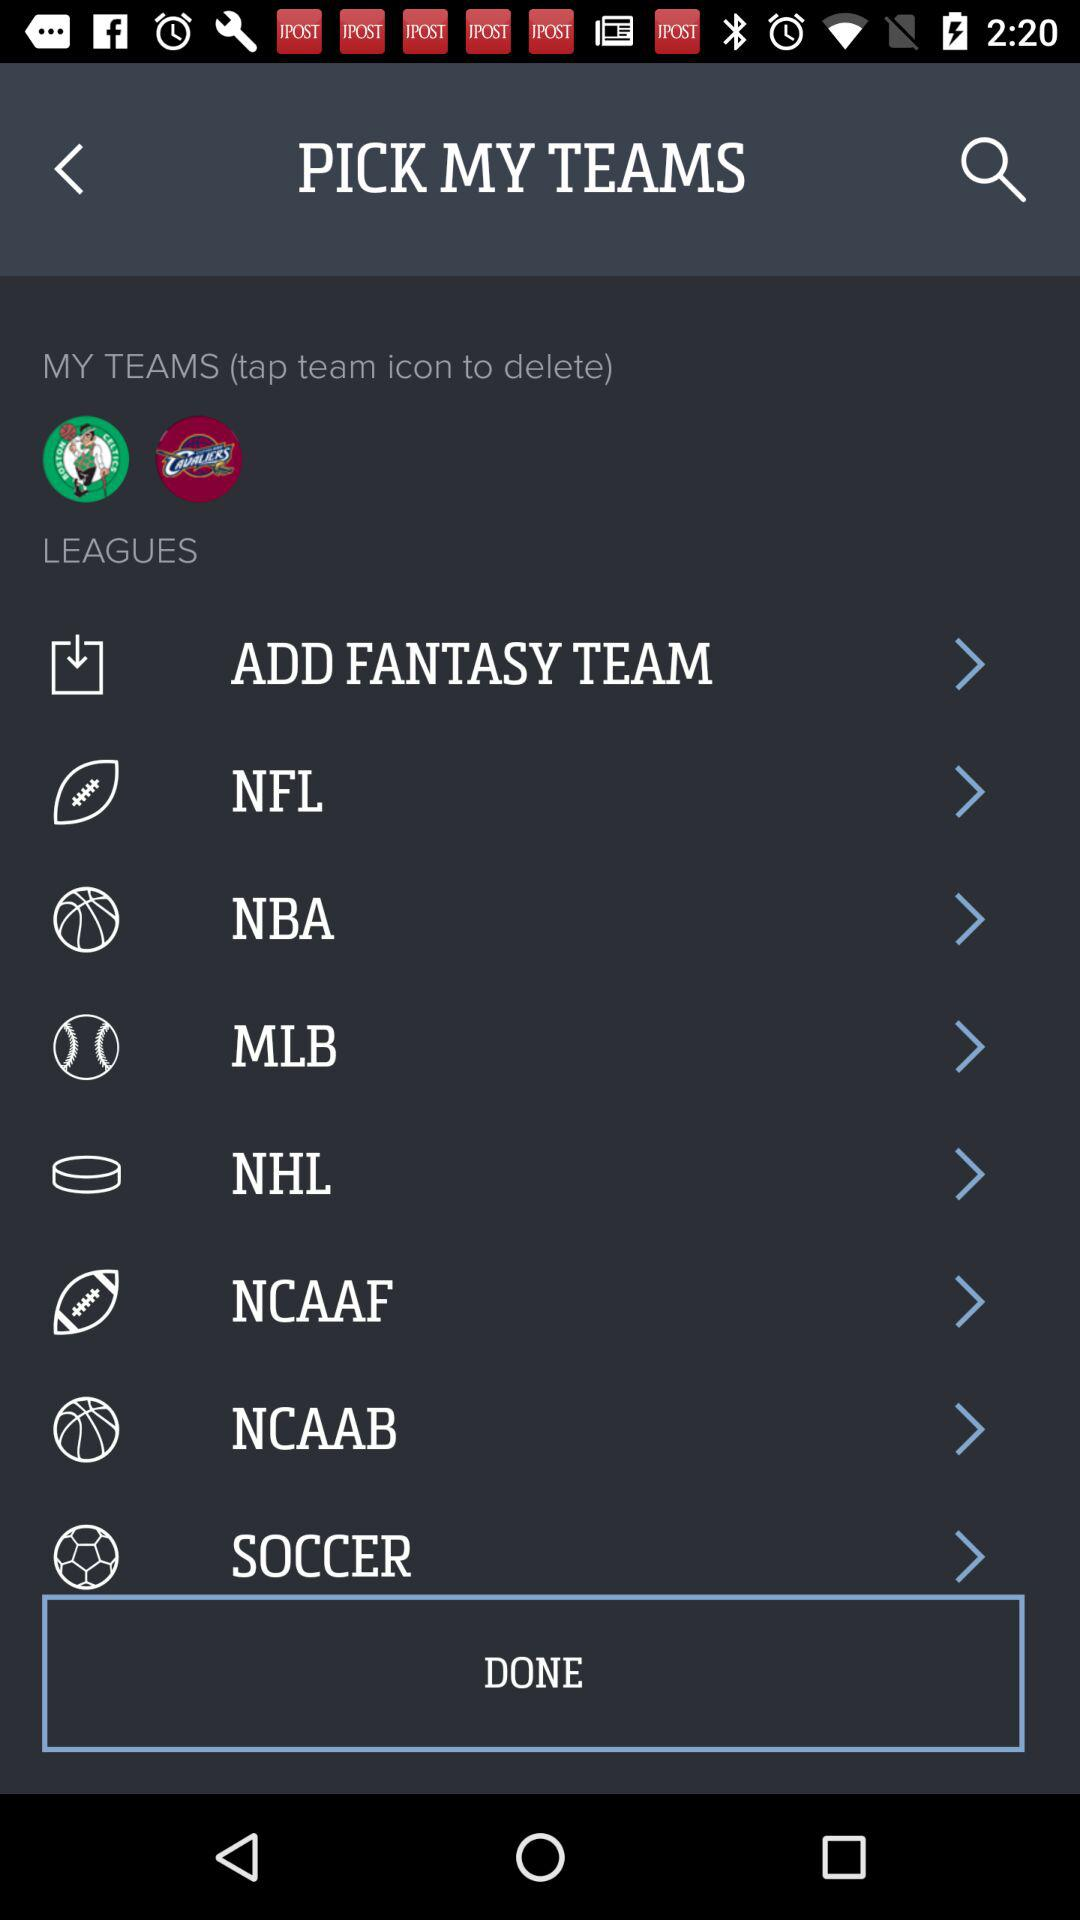How many teams are currently selected?
Answer the question using a single word or phrase. 2 